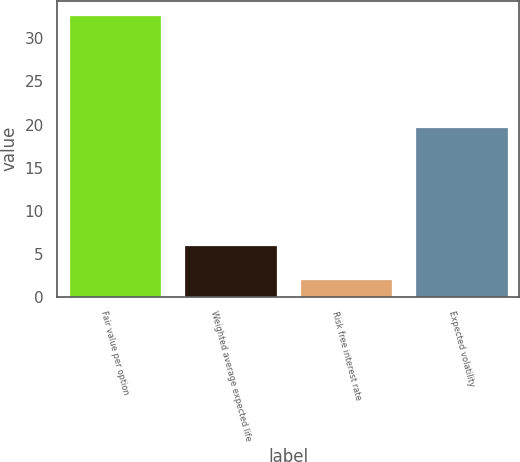Convert chart. <chart><loc_0><loc_0><loc_500><loc_500><bar_chart><fcel>Fair value per option<fcel>Weighted average expected life<fcel>Risk free interest rate<fcel>Expected volatility<nl><fcel>32.75<fcel>6<fcel>2.1<fcel>19.7<nl></chart> 